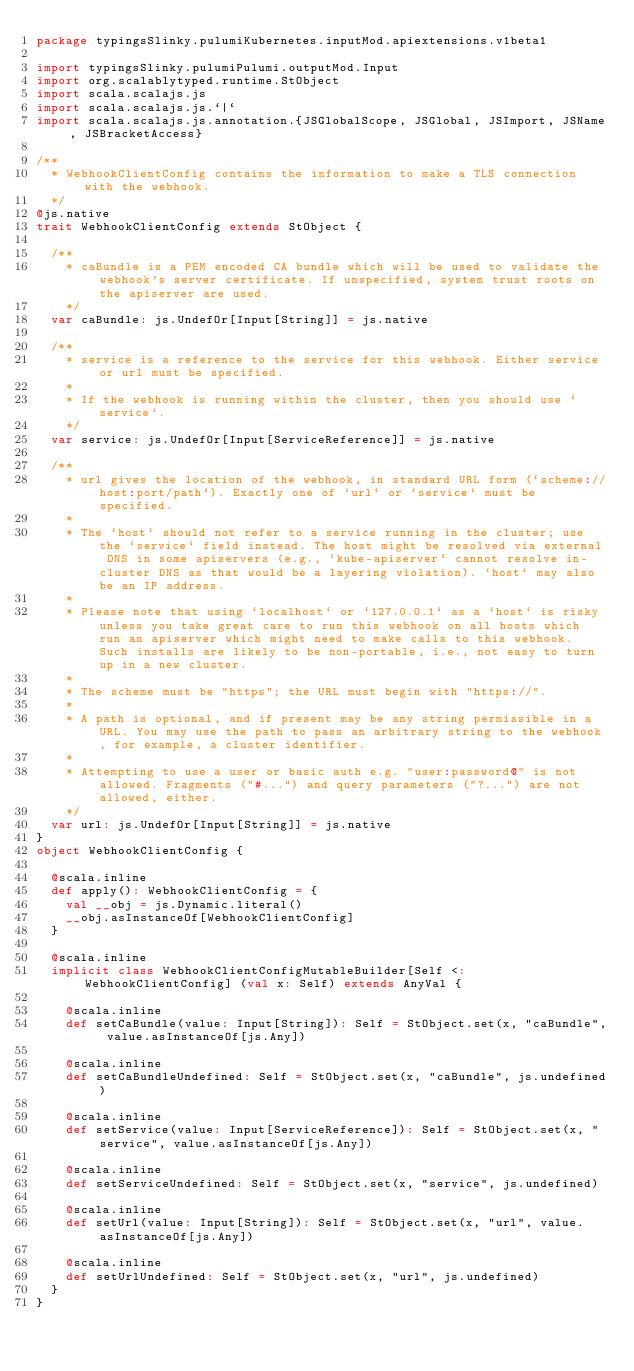Convert code to text. <code><loc_0><loc_0><loc_500><loc_500><_Scala_>package typingsSlinky.pulumiKubernetes.inputMod.apiextensions.v1beta1

import typingsSlinky.pulumiPulumi.outputMod.Input
import org.scalablytyped.runtime.StObject
import scala.scalajs.js
import scala.scalajs.js.`|`
import scala.scalajs.js.annotation.{JSGlobalScope, JSGlobal, JSImport, JSName, JSBracketAccess}

/**
  * WebhookClientConfig contains the information to make a TLS connection with the webhook.
  */
@js.native
trait WebhookClientConfig extends StObject {
  
  /**
    * caBundle is a PEM encoded CA bundle which will be used to validate the webhook's server certificate. If unspecified, system trust roots on the apiserver are used.
    */
  var caBundle: js.UndefOr[Input[String]] = js.native
  
  /**
    * service is a reference to the service for this webhook. Either service or url must be specified.
    *
    * If the webhook is running within the cluster, then you should use `service`.
    */
  var service: js.UndefOr[Input[ServiceReference]] = js.native
  
  /**
    * url gives the location of the webhook, in standard URL form (`scheme://host:port/path`). Exactly one of `url` or `service` must be specified.
    *
    * The `host` should not refer to a service running in the cluster; use the `service` field instead. The host might be resolved via external DNS in some apiservers (e.g., `kube-apiserver` cannot resolve in-cluster DNS as that would be a layering violation). `host` may also be an IP address.
    *
    * Please note that using `localhost` or `127.0.0.1` as a `host` is risky unless you take great care to run this webhook on all hosts which run an apiserver which might need to make calls to this webhook. Such installs are likely to be non-portable, i.e., not easy to turn up in a new cluster.
    *
    * The scheme must be "https"; the URL must begin with "https://".
    *
    * A path is optional, and if present may be any string permissible in a URL. You may use the path to pass an arbitrary string to the webhook, for example, a cluster identifier.
    *
    * Attempting to use a user or basic auth e.g. "user:password@" is not allowed. Fragments ("#...") and query parameters ("?...") are not allowed, either.
    */
  var url: js.UndefOr[Input[String]] = js.native
}
object WebhookClientConfig {
  
  @scala.inline
  def apply(): WebhookClientConfig = {
    val __obj = js.Dynamic.literal()
    __obj.asInstanceOf[WebhookClientConfig]
  }
  
  @scala.inline
  implicit class WebhookClientConfigMutableBuilder[Self <: WebhookClientConfig] (val x: Self) extends AnyVal {
    
    @scala.inline
    def setCaBundle(value: Input[String]): Self = StObject.set(x, "caBundle", value.asInstanceOf[js.Any])
    
    @scala.inline
    def setCaBundleUndefined: Self = StObject.set(x, "caBundle", js.undefined)
    
    @scala.inline
    def setService(value: Input[ServiceReference]): Self = StObject.set(x, "service", value.asInstanceOf[js.Any])
    
    @scala.inline
    def setServiceUndefined: Self = StObject.set(x, "service", js.undefined)
    
    @scala.inline
    def setUrl(value: Input[String]): Self = StObject.set(x, "url", value.asInstanceOf[js.Any])
    
    @scala.inline
    def setUrlUndefined: Self = StObject.set(x, "url", js.undefined)
  }
}
</code> 